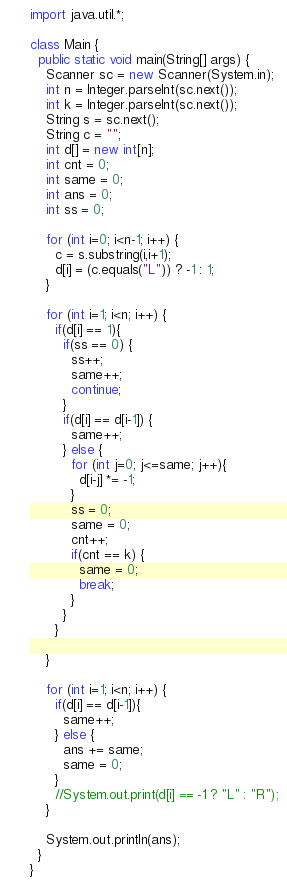<code> <loc_0><loc_0><loc_500><loc_500><_Java_>import java.util.*;

class Main {
  public static void main(String[] args) {
    Scanner sc = new Scanner(System.in);
    int n = Integer.parseInt(sc.next());
    int k = Integer.parseInt(sc.next());
    String s = sc.next();
    String c = "";
    int d[] = new int[n];
    int cnt = 0;
    int same = 0;
    int ans = 0;
    int ss = 0;
    
    for (int i=0; i<n-1; i++) {
      c = s.substring(i,i+1);
      d[i] = (c.equals("L")) ? -1 : 1;
    }
    
    for (int i=1; i<n; i++) {
      if(d[i] == 1){
        if(ss == 0) {
          ss++;
          same++;
          continue;
        }
        if(d[i] == d[i-1]) {
          same++;
        } else {
          for (int j=0; j<=same; j++){
            d[i-j] *= -1;
          }
          ss = 0;
          same = 0;
          cnt++;
          if(cnt == k) {
            same = 0; 
            break;
          }
        }
      }
      
    }

    for (int i=1; i<n; i++) {
      if(d[i] == d[i-1]){
        same++; 
      } else {
        ans += same;
        same = 0;
      }
      //System.out.print(d[i] == -1 ? "L" : "R");
    }
    
    System.out.println(ans);
  }
}
</code> 